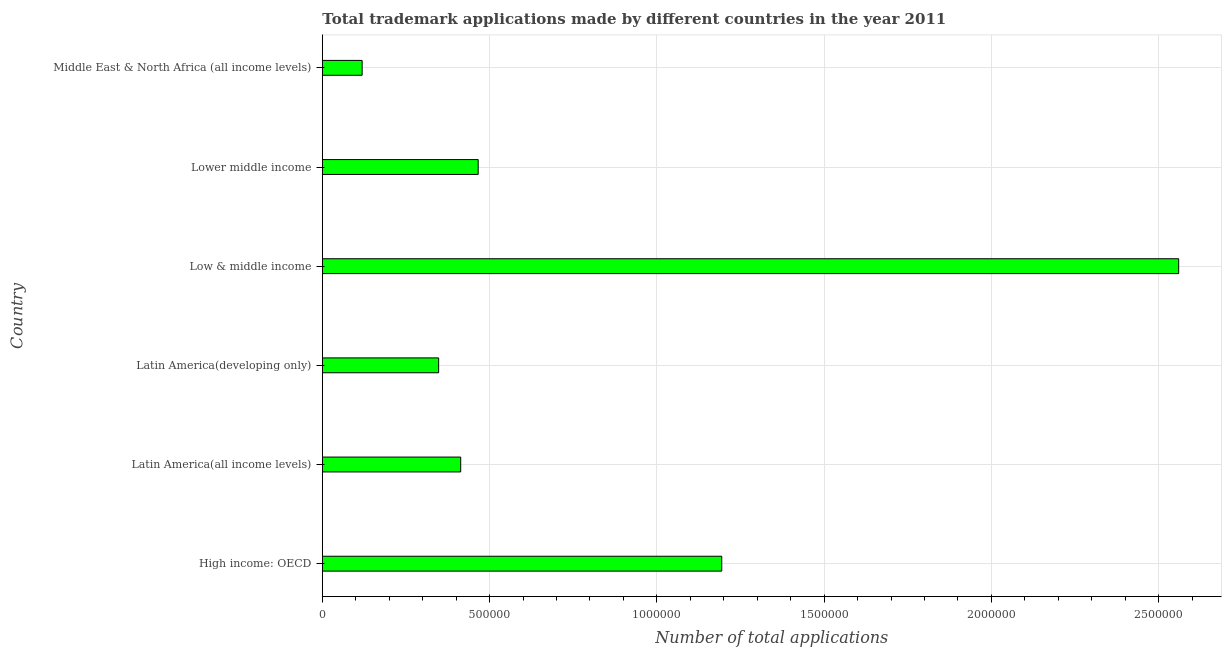What is the title of the graph?
Provide a short and direct response. Total trademark applications made by different countries in the year 2011. What is the label or title of the X-axis?
Make the answer very short. Number of total applications. What is the number of trademark applications in Latin America(developing only)?
Offer a terse response. 3.48e+05. Across all countries, what is the maximum number of trademark applications?
Your answer should be very brief. 2.56e+06. Across all countries, what is the minimum number of trademark applications?
Keep it short and to the point. 1.19e+05. In which country was the number of trademark applications maximum?
Offer a terse response. Low & middle income. In which country was the number of trademark applications minimum?
Ensure brevity in your answer.  Middle East & North Africa (all income levels). What is the sum of the number of trademark applications?
Offer a very short reply. 5.10e+06. What is the difference between the number of trademark applications in Low & middle income and Middle East & North Africa (all income levels)?
Keep it short and to the point. 2.44e+06. What is the average number of trademark applications per country?
Ensure brevity in your answer.  8.50e+05. What is the median number of trademark applications?
Offer a very short reply. 4.40e+05. In how many countries, is the number of trademark applications greater than 900000 ?
Provide a succinct answer. 2. What is the ratio of the number of trademark applications in Latin America(all income levels) to that in Lower middle income?
Offer a terse response. 0.89. Is the difference between the number of trademark applications in High income: OECD and Latin America(developing only) greater than the difference between any two countries?
Provide a succinct answer. No. What is the difference between the highest and the second highest number of trademark applications?
Give a very brief answer. 1.37e+06. What is the difference between the highest and the lowest number of trademark applications?
Provide a short and direct response. 2.44e+06. How many bars are there?
Your response must be concise. 6. Are all the bars in the graph horizontal?
Provide a short and direct response. Yes. How many countries are there in the graph?
Provide a succinct answer. 6. What is the Number of total applications in High income: OECD?
Provide a succinct answer. 1.19e+06. What is the Number of total applications of Latin America(all income levels)?
Provide a short and direct response. 4.14e+05. What is the Number of total applications of Latin America(developing only)?
Your answer should be very brief. 3.48e+05. What is the Number of total applications of Low & middle income?
Provide a succinct answer. 2.56e+06. What is the Number of total applications of Lower middle income?
Your answer should be very brief. 4.66e+05. What is the Number of total applications in Middle East & North Africa (all income levels)?
Offer a very short reply. 1.19e+05. What is the difference between the Number of total applications in High income: OECD and Latin America(all income levels)?
Your answer should be compact. 7.80e+05. What is the difference between the Number of total applications in High income: OECD and Latin America(developing only)?
Provide a succinct answer. 8.46e+05. What is the difference between the Number of total applications in High income: OECD and Low & middle income?
Offer a terse response. -1.37e+06. What is the difference between the Number of total applications in High income: OECD and Lower middle income?
Your response must be concise. 7.28e+05. What is the difference between the Number of total applications in High income: OECD and Middle East & North Africa (all income levels)?
Keep it short and to the point. 1.07e+06. What is the difference between the Number of total applications in Latin America(all income levels) and Latin America(developing only)?
Your answer should be compact. 6.60e+04. What is the difference between the Number of total applications in Latin America(all income levels) and Low & middle income?
Make the answer very short. -2.15e+06. What is the difference between the Number of total applications in Latin America(all income levels) and Lower middle income?
Your answer should be compact. -5.22e+04. What is the difference between the Number of total applications in Latin America(all income levels) and Middle East & North Africa (all income levels)?
Your response must be concise. 2.95e+05. What is the difference between the Number of total applications in Latin America(developing only) and Low & middle income?
Ensure brevity in your answer.  -2.21e+06. What is the difference between the Number of total applications in Latin America(developing only) and Lower middle income?
Offer a very short reply. -1.18e+05. What is the difference between the Number of total applications in Latin America(developing only) and Middle East & North Africa (all income levels)?
Your response must be concise. 2.29e+05. What is the difference between the Number of total applications in Low & middle income and Lower middle income?
Give a very brief answer. 2.09e+06. What is the difference between the Number of total applications in Low & middle income and Middle East & North Africa (all income levels)?
Provide a short and direct response. 2.44e+06. What is the difference between the Number of total applications in Lower middle income and Middle East & North Africa (all income levels)?
Provide a succinct answer. 3.47e+05. What is the ratio of the Number of total applications in High income: OECD to that in Latin America(all income levels)?
Offer a terse response. 2.89. What is the ratio of the Number of total applications in High income: OECD to that in Latin America(developing only)?
Your response must be concise. 3.43. What is the ratio of the Number of total applications in High income: OECD to that in Low & middle income?
Offer a terse response. 0.47. What is the ratio of the Number of total applications in High income: OECD to that in Lower middle income?
Provide a short and direct response. 2.56. What is the ratio of the Number of total applications in High income: OECD to that in Middle East & North Africa (all income levels)?
Make the answer very short. 10.03. What is the ratio of the Number of total applications in Latin America(all income levels) to that in Latin America(developing only)?
Make the answer very short. 1.19. What is the ratio of the Number of total applications in Latin America(all income levels) to that in Low & middle income?
Ensure brevity in your answer.  0.16. What is the ratio of the Number of total applications in Latin America(all income levels) to that in Lower middle income?
Offer a terse response. 0.89. What is the ratio of the Number of total applications in Latin America(all income levels) to that in Middle East & North Africa (all income levels)?
Give a very brief answer. 3.48. What is the ratio of the Number of total applications in Latin America(developing only) to that in Low & middle income?
Make the answer very short. 0.14. What is the ratio of the Number of total applications in Latin America(developing only) to that in Lower middle income?
Offer a very short reply. 0.75. What is the ratio of the Number of total applications in Latin America(developing only) to that in Middle East & North Africa (all income levels)?
Provide a succinct answer. 2.92. What is the ratio of the Number of total applications in Low & middle income to that in Lower middle income?
Provide a succinct answer. 5.5. What is the ratio of the Number of total applications in Low & middle income to that in Middle East & North Africa (all income levels)?
Your answer should be very brief. 21.51. What is the ratio of the Number of total applications in Lower middle income to that in Middle East & North Africa (all income levels)?
Make the answer very short. 3.92. 